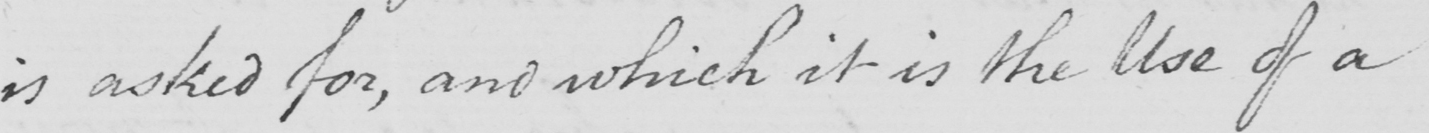Can you read and transcribe this handwriting? is asked for , and which it is the Use of a 